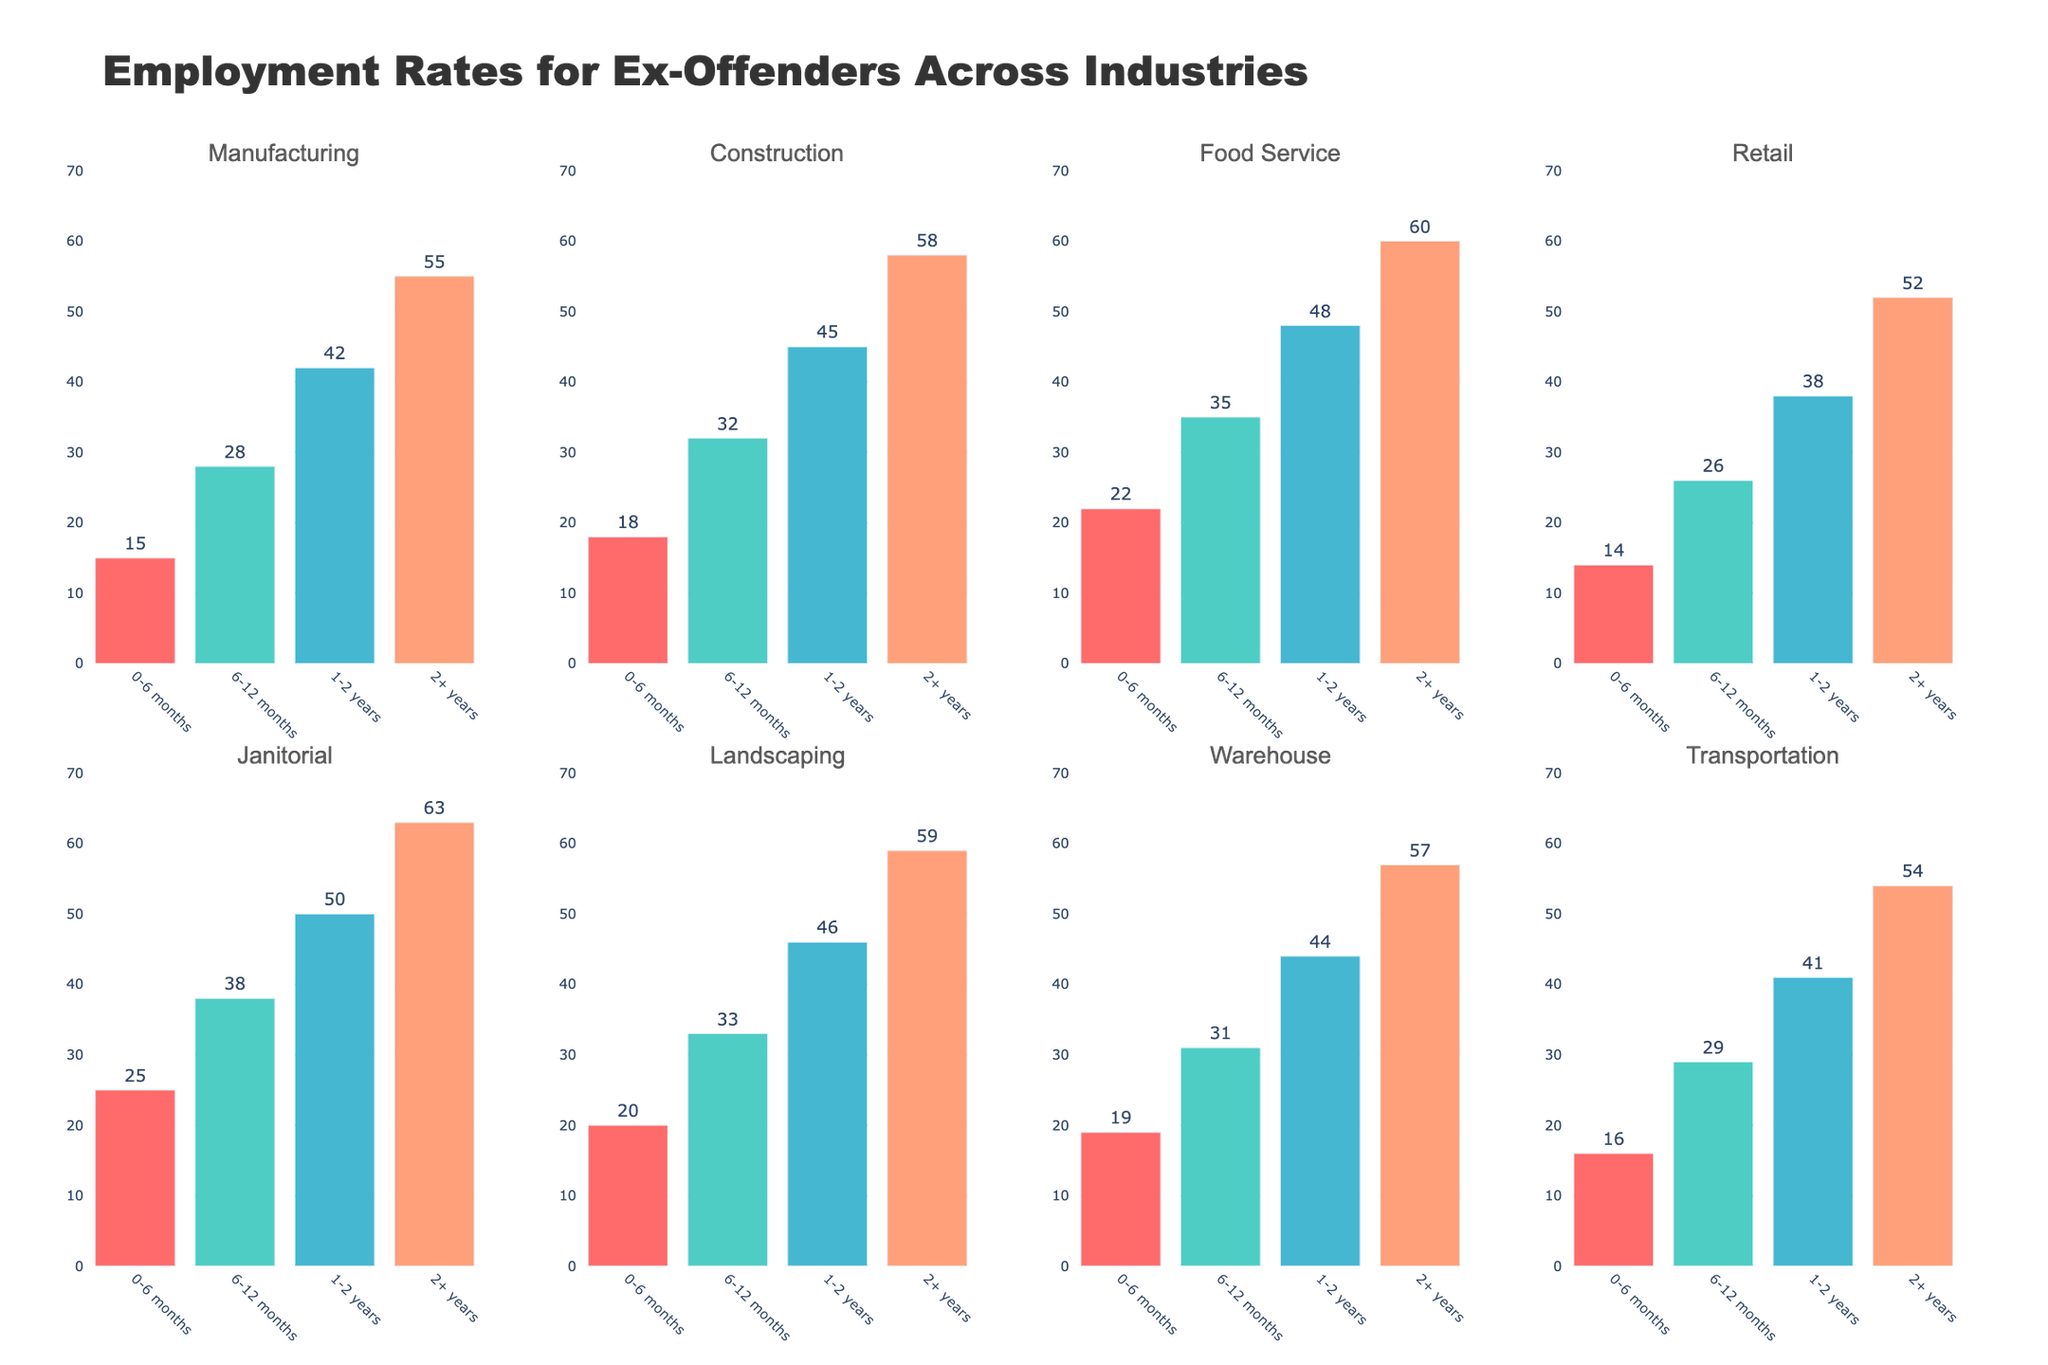What is the title of the figure? The title of the figure is located at the top center of the plot and it provides an overview of the topic being displayed.
Answer: Employment Rates for Ex-Offenders Across Industries How many subplots are there in the figure? By counting the individual plots for each industry, you can determine the total number of subplots.
Answer: 8 Which industry shows the highest employment rate for ex-offenders in the 0-6 months period? Look at the bars for the 0-6 months period in each subplot and compare their heights to find the highest one.
Answer: Janitorial By how much did the employment rate in Construction increase from the 0-6 months period to the 1-2 years period? Subtract the value of the 0-6 months bar from the value of the 1-2 years bar in the Construction subplot.
Answer: 27 Which time period has the highest employment rate in the Warehouse industry? Examine the bars in the Warehouse industry subplot and identify the one with the highest value.
Answer: 2+ years Compare the employment rates for ex-offenders in the Food Service and Retail industries for the 6-12 months period. Which is higher? Find and compare the heights of the bars for the 6-12 months period in both the Food Service and Retail subplots.
Answer: Food Service What is the range of the y-axes in the subplots? Look at the y-axes on any of the subplots to determine the minimum and maximum values displayed.
Answer: 0 to 70 What is the pattern of employment rates across all time periods in the Landscaping industry? Observe the trend in the heights of the bars for each time period in the Landscaping subplot.
Answer: Increasing How much higher is the employment rate in the Transportation industry at 2+ years compared to 6-12 months? Subtract the value of the 6-12 months bar from the value of the 2+ years bar in the Transportation subplot.
Answer: 25 